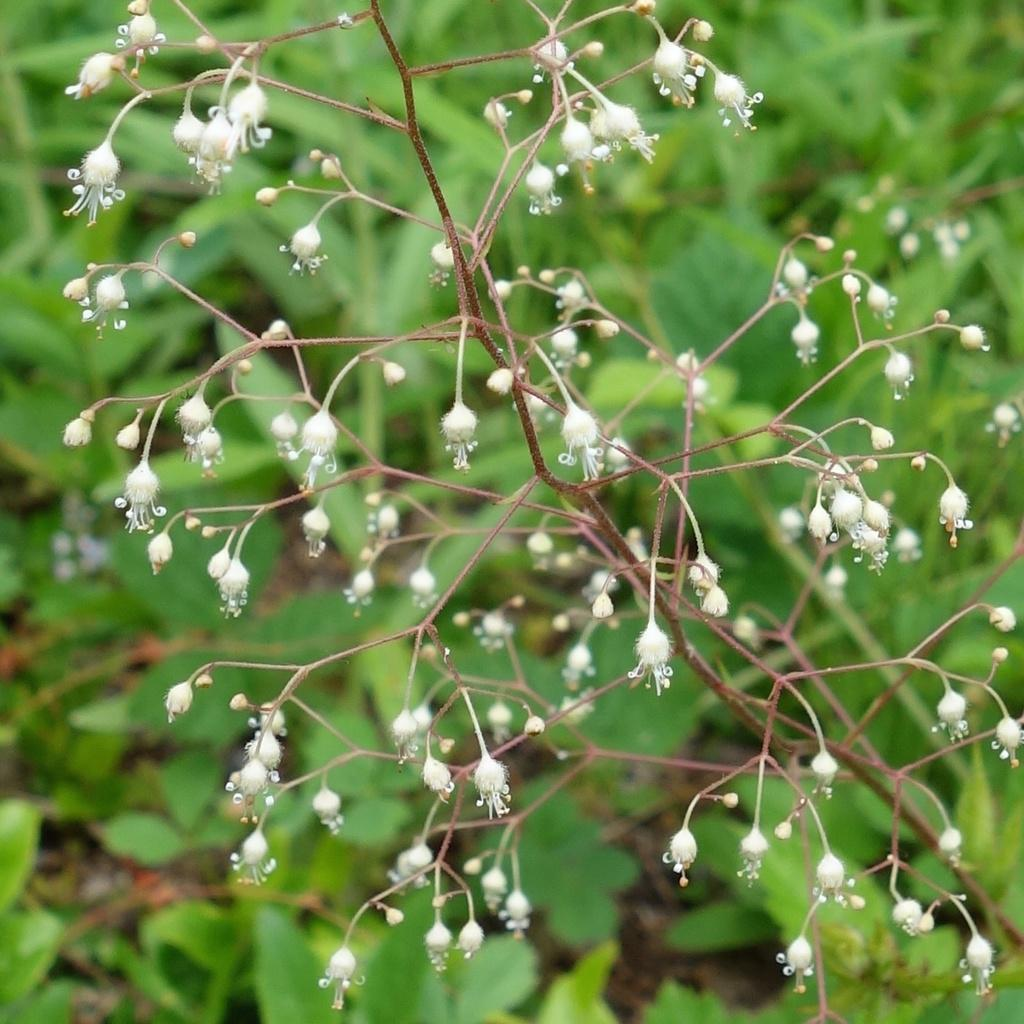What color are the flowers in the image? The flowers in the image are white. How many flowers are on the stem? The provided facts do not specify the exact number of flowers on the stem. What can be seen in the background of the image? The background of the image is green and blurred. What disease is the flower suffering from in the image? There is no indication in the image that the flower is suffering from any disease. Can you tell me the story behind the flower in the image? The provided facts do not give any information about the story behind the flower in the image. 